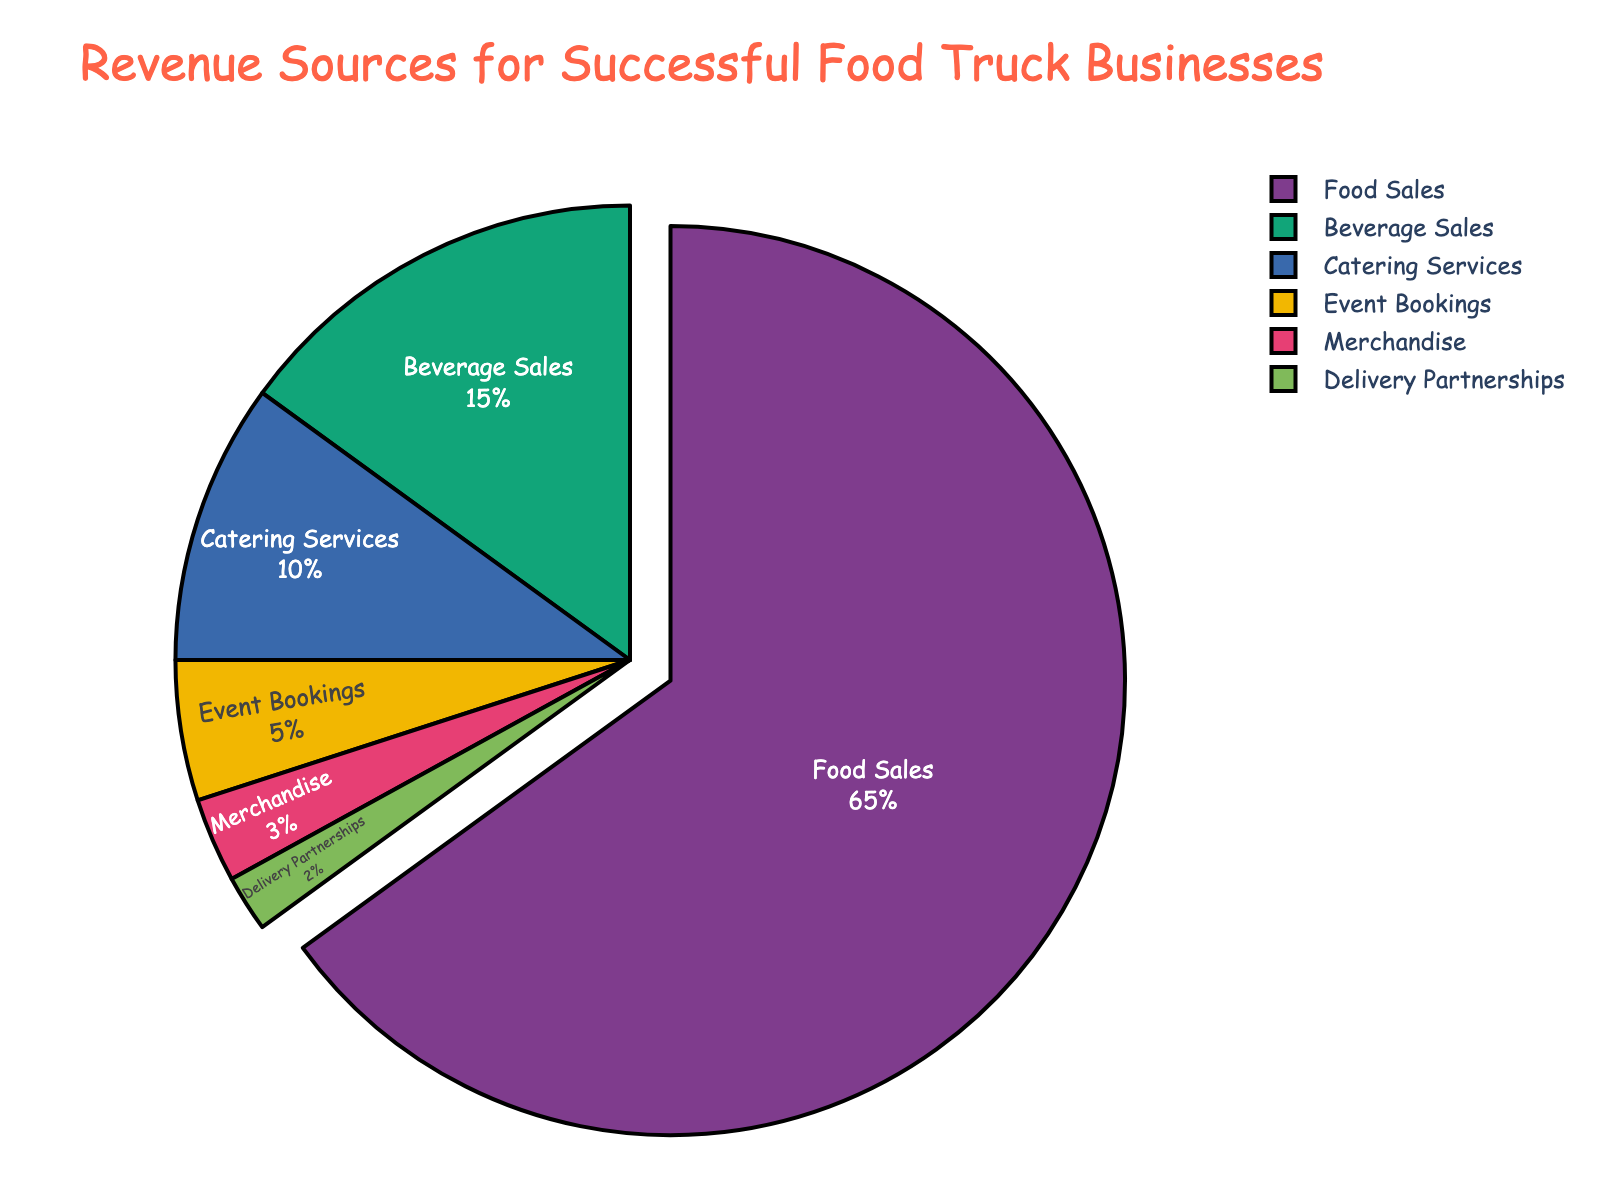What's the largest revenue source for successful food truck businesses? By looking at the size of each slice in the pie chart, we can observe that "Food Sales" represents the largest portion of the chart with 65%.
Answer: Food Sales How much more revenue does "Beverage Sales" generate compared to "Catering Services"? The percentage of revenue from "Beverage Sales" is 15% and from "Catering Services" is 10%. The difference is calculated by subtracting 10 from 15.
Answer: 5% What is the total percentage of revenue from "Event Bookings" and "Merchandise"? The percentage of revenue from "Event Bookings" is 5% and from "Merchandise" is 3%. Adding these two percentages together gives us the total. 5 + 3 = 8
Answer: 8% Which category contributes the least to the revenue? By observing the smallest slice in the pie chart, we can see that "Delivery Partnerships" contributes the least to the revenue with 2%.
Answer: Delivery Partnerships Compare the revenue percentages from "Catering Services" and "Event Bookings". Which one is greater and by how much? The percentage for "Catering Services" is 10% and for "Event Bookings" is 5%. Subtract 5 from 10 to find out how much greater "Catering Services" is.
Answer: Catering Services by 5% What percentage of total revenue comes from categories other than "Food Sales"? The percentage for "Food Sales" is 65%. To find the percentage from all other categories, subtract 65% from 100% (total). 100 - 65 = 35
Answer: 35% If we combine "Merchandise" and "Delivery Partnerships", do they account for more or less revenue than "Event Bookings"? The percentages for "Merchandise" and "Delivery Partnerships" are 3% and 2% respectively. Their total is 3 + 2 = 5%. "Event Bookings" also accounts for 5%, so they are equal.
Answer: Equal Which categories have a revenue contribution of less than 10%? By inspecting the chart, we can see that "Event Bookings" (5%), "Merchandise" (3%), and "Delivery Partnerships" (2%) are the categories with less than 10% revenue contribution.
Answer: Event Bookings, Merchandise, Delivery Partnerships What percentage does "Catering Services" and "Beverage Sales" contribute together? The percentages for "Catering Services" and "Beverage Sales" are 10% and 15%, respectively. Adding them together gives 10 + 15 = 25%.
Answer: 25% What part of the pie chart is highlighted slightly more than others? Observing the pie chart, we can see that the slice for "Food Sales" is pulled out slightly more compared to others, indicating it is highlighted.
Answer: Food Sales 